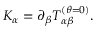<formula> <loc_0><loc_0><loc_500><loc_500>K _ { \alpha } = \partial _ { \beta } T _ { \alpha \beta } ^ { ( \theta = 0 ) } .</formula> 